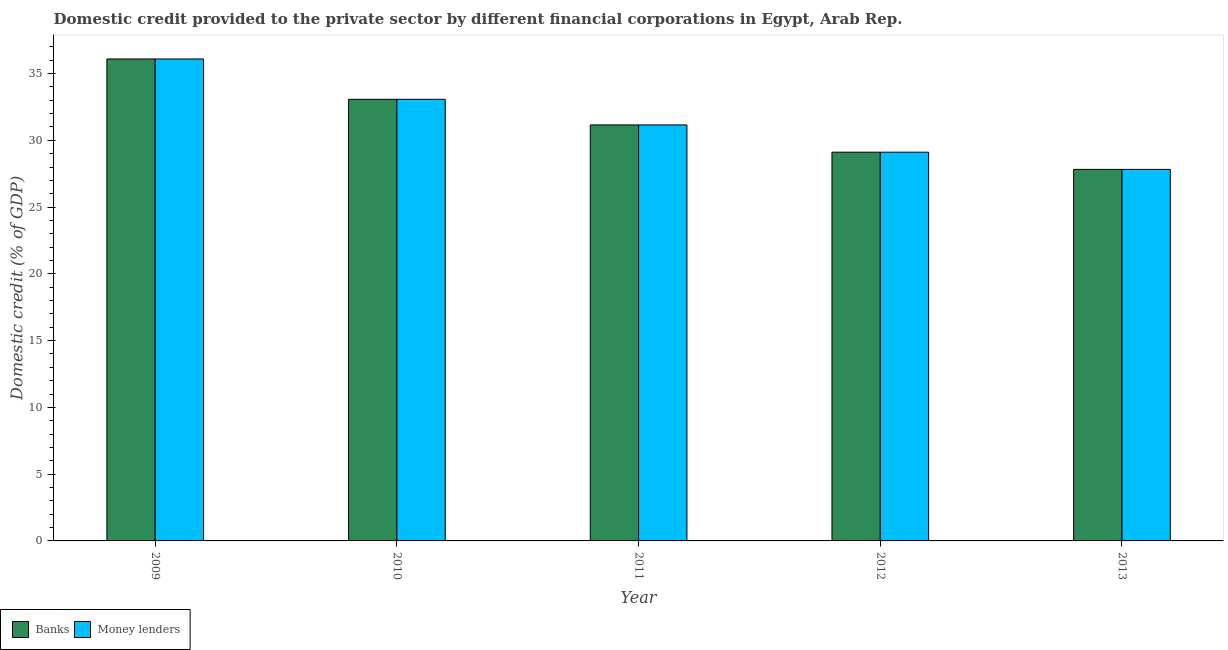Are the number of bars per tick equal to the number of legend labels?
Your answer should be compact. Yes. What is the domestic credit provided by banks in 2011?
Provide a succinct answer. 31.15. Across all years, what is the maximum domestic credit provided by money lenders?
Ensure brevity in your answer.  36.09. Across all years, what is the minimum domestic credit provided by money lenders?
Your response must be concise. 27.82. In which year was the domestic credit provided by money lenders maximum?
Give a very brief answer. 2009. What is the total domestic credit provided by money lenders in the graph?
Your response must be concise. 157.26. What is the difference between the domestic credit provided by banks in 2009 and that in 2011?
Your response must be concise. 4.94. What is the difference between the domestic credit provided by banks in 2011 and the domestic credit provided by money lenders in 2010?
Keep it short and to the point. -1.92. What is the average domestic credit provided by banks per year?
Offer a terse response. 31.45. In the year 2011, what is the difference between the domestic credit provided by banks and domestic credit provided by money lenders?
Your answer should be very brief. 0. What is the ratio of the domestic credit provided by money lenders in 2009 to that in 2012?
Ensure brevity in your answer.  1.24. Is the difference between the domestic credit provided by money lenders in 2012 and 2013 greater than the difference between the domestic credit provided by banks in 2012 and 2013?
Your answer should be compact. No. What is the difference between the highest and the second highest domestic credit provided by banks?
Your response must be concise. 3.02. What is the difference between the highest and the lowest domestic credit provided by money lenders?
Keep it short and to the point. 8.27. In how many years, is the domestic credit provided by banks greater than the average domestic credit provided by banks taken over all years?
Give a very brief answer. 2. What does the 2nd bar from the left in 2011 represents?
Your response must be concise. Money lenders. What does the 2nd bar from the right in 2013 represents?
Make the answer very short. Banks. How many years are there in the graph?
Offer a very short reply. 5. What is the difference between two consecutive major ticks on the Y-axis?
Your response must be concise. 5. Are the values on the major ticks of Y-axis written in scientific E-notation?
Provide a succinct answer. No. Does the graph contain grids?
Provide a short and direct response. No. How many legend labels are there?
Provide a succinct answer. 2. How are the legend labels stacked?
Provide a succinct answer. Horizontal. What is the title of the graph?
Ensure brevity in your answer.  Domestic credit provided to the private sector by different financial corporations in Egypt, Arab Rep. What is the label or title of the X-axis?
Make the answer very short. Year. What is the label or title of the Y-axis?
Give a very brief answer. Domestic credit (% of GDP). What is the Domestic credit (% of GDP) in Banks in 2009?
Provide a short and direct response. 36.09. What is the Domestic credit (% of GDP) in Money lenders in 2009?
Offer a very short reply. 36.09. What is the Domestic credit (% of GDP) of Banks in 2010?
Offer a very short reply. 33.07. What is the Domestic credit (% of GDP) of Money lenders in 2010?
Provide a short and direct response. 33.07. What is the Domestic credit (% of GDP) of Banks in 2011?
Make the answer very short. 31.15. What is the Domestic credit (% of GDP) of Money lenders in 2011?
Provide a short and direct response. 31.15. What is the Domestic credit (% of GDP) in Banks in 2012?
Your answer should be compact. 29.11. What is the Domestic credit (% of GDP) in Money lenders in 2012?
Offer a terse response. 29.11. What is the Domestic credit (% of GDP) in Banks in 2013?
Provide a succinct answer. 27.82. What is the Domestic credit (% of GDP) in Money lenders in 2013?
Give a very brief answer. 27.82. Across all years, what is the maximum Domestic credit (% of GDP) of Banks?
Make the answer very short. 36.09. Across all years, what is the maximum Domestic credit (% of GDP) of Money lenders?
Your answer should be very brief. 36.09. Across all years, what is the minimum Domestic credit (% of GDP) of Banks?
Offer a terse response. 27.82. Across all years, what is the minimum Domestic credit (% of GDP) of Money lenders?
Provide a succinct answer. 27.82. What is the total Domestic credit (% of GDP) in Banks in the graph?
Give a very brief answer. 157.26. What is the total Domestic credit (% of GDP) in Money lenders in the graph?
Give a very brief answer. 157.26. What is the difference between the Domestic credit (% of GDP) of Banks in 2009 and that in 2010?
Give a very brief answer. 3.02. What is the difference between the Domestic credit (% of GDP) of Money lenders in 2009 and that in 2010?
Make the answer very short. 3.02. What is the difference between the Domestic credit (% of GDP) in Banks in 2009 and that in 2011?
Your answer should be compact. 4.94. What is the difference between the Domestic credit (% of GDP) of Money lenders in 2009 and that in 2011?
Provide a short and direct response. 4.94. What is the difference between the Domestic credit (% of GDP) in Banks in 2009 and that in 2012?
Offer a very short reply. 6.98. What is the difference between the Domestic credit (% of GDP) in Money lenders in 2009 and that in 2012?
Provide a succinct answer. 6.98. What is the difference between the Domestic credit (% of GDP) of Banks in 2009 and that in 2013?
Offer a terse response. 8.27. What is the difference between the Domestic credit (% of GDP) of Money lenders in 2009 and that in 2013?
Give a very brief answer. 8.27. What is the difference between the Domestic credit (% of GDP) of Banks in 2010 and that in 2011?
Provide a succinct answer. 1.92. What is the difference between the Domestic credit (% of GDP) in Money lenders in 2010 and that in 2011?
Offer a terse response. 1.92. What is the difference between the Domestic credit (% of GDP) in Banks in 2010 and that in 2012?
Offer a terse response. 3.96. What is the difference between the Domestic credit (% of GDP) of Money lenders in 2010 and that in 2012?
Make the answer very short. 3.96. What is the difference between the Domestic credit (% of GDP) of Banks in 2010 and that in 2013?
Ensure brevity in your answer.  5.25. What is the difference between the Domestic credit (% of GDP) of Money lenders in 2010 and that in 2013?
Your answer should be very brief. 5.25. What is the difference between the Domestic credit (% of GDP) of Banks in 2011 and that in 2012?
Offer a very short reply. 2.04. What is the difference between the Domestic credit (% of GDP) of Money lenders in 2011 and that in 2012?
Keep it short and to the point. 2.04. What is the difference between the Domestic credit (% of GDP) in Banks in 2011 and that in 2013?
Ensure brevity in your answer.  3.33. What is the difference between the Domestic credit (% of GDP) of Money lenders in 2011 and that in 2013?
Ensure brevity in your answer.  3.33. What is the difference between the Domestic credit (% of GDP) in Banks in 2012 and that in 2013?
Your response must be concise. 1.29. What is the difference between the Domestic credit (% of GDP) in Money lenders in 2012 and that in 2013?
Offer a very short reply. 1.29. What is the difference between the Domestic credit (% of GDP) of Banks in 2009 and the Domestic credit (% of GDP) of Money lenders in 2010?
Your answer should be very brief. 3.02. What is the difference between the Domestic credit (% of GDP) in Banks in 2009 and the Domestic credit (% of GDP) in Money lenders in 2011?
Provide a succinct answer. 4.94. What is the difference between the Domestic credit (% of GDP) in Banks in 2009 and the Domestic credit (% of GDP) in Money lenders in 2012?
Make the answer very short. 6.98. What is the difference between the Domestic credit (% of GDP) of Banks in 2009 and the Domestic credit (% of GDP) of Money lenders in 2013?
Your response must be concise. 8.27. What is the difference between the Domestic credit (% of GDP) of Banks in 2010 and the Domestic credit (% of GDP) of Money lenders in 2011?
Offer a terse response. 1.92. What is the difference between the Domestic credit (% of GDP) of Banks in 2010 and the Domestic credit (% of GDP) of Money lenders in 2012?
Offer a terse response. 3.96. What is the difference between the Domestic credit (% of GDP) in Banks in 2010 and the Domestic credit (% of GDP) in Money lenders in 2013?
Ensure brevity in your answer.  5.25. What is the difference between the Domestic credit (% of GDP) in Banks in 2011 and the Domestic credit (% of GDP) in Money lenders in 2012?
Keep it short and to the point. 2.04. What is the difference between the Domestic credit (% of GDP) in Banks in 2011 and the Domestic credit (% of GDP) in Money lenders in 2013?
Your answer should be very brief. 3.33. What is the difference between the Domestic credit (% of GDP) of Banks in 2012 and the Domestic credit (% of GDP) of Money lenders in 2013?
Keep it short and to the point. 1.29. What is the average Domestic credit (% of GDP) of Banks per year?
Offer a terse response. 31.45. What is the average Domestic credit (% of GDP) in Money lenders per year?
Provide a succinct answer. 31.45. In the year 2009, what is the difference between the Domestic credit (% of GDP) in Banks and Domestic credit (% of GDP) in Money lenders?
Offer a terse response. 0. In the year 2011, what is the difference between the Domestic credit (% of GDP) of Banks and Domestic credit (% of GDP) of Money lenders?
Offer a terse response. 0. In the year 2012, what is the difference between the Domestic credit (% of GDP) in Banks and Domestic credit (% of GDP) in Money lenders?
Offer a terse response. 0. In the year 2013, what is the difference between the Domestic credit (% of GDP) of Banks and Domestic credit (% of GDP) of Money lenders?
Make the answer very short. 0. What is the ratio of the Domestic credit (% of GDP) of Banks in 2009 to that in 2010?
Your answer should be very brief. 1.09. What is the ratio of the Domestic credit (% of GDP) of Money lenders in 2009 to that in 2010?
Keep it short and to the point. 1.09. What is the ratio of the Domestic credit (% of GDP) in Banks in 2009 to that in 2011?
Make the answer very short. 1.16. What is the ratio of the Domestic credit (% of GDP) of Money lenders in 2009 to that in 2011?
Provide a succinct answer. 1.16. What is the ratio of the Domestic credit (% of GDP) in Banks in 2009 to that in 2012?
Make the answer very short. 1.24. What is the ratio of the Domestic credit (% of GDP) of Money lenders in 2009 to that in 2012?
Keep it short and to the point. 1.24. What is the ratio of the Domestic credit (% of GDP) of Banks in 2009 to that in 2013?
Your answer should be very brief. 1.3. What is the ratio of the Domestic credit (% of GDP) of Money lenders in 2009 to that in 2013?
Your response must be concise. 1.3. What is the ratio of the Domestic credit (% of GDP) in Banks in 2010 to that in 2011?
Ensure brevity in your answer.  1.06. What is the ratio of the Domestic credit (% of GDP) in Money lenders in 2010 to that in 2011?
Offer a terse response. 1.06. What is the ratio of the Domestic credit (% of GDP) of Banks in 2010 to that in 2012?
Give a very brief answer. 1.14. What is the ratio of the Domestic credit (% of GDP) in Money lenders in 2010 to that in 2012?
Offer a very short reply. 1.14. What is the ratio of the Domestic credit (% of GDP) in Banks in 2010 to that in 2013?
Make the answer very short. 1.19. What is the ratio of the Domestic credit (% of GDP) in Money lenders in 2010 to that in 2013?
Keep it short and to the point. 1.19. What is the ratio of the Domestic credit (% of GDP) in Banks in 2011 to that in 2012?
Your answer should be compact. 1.07. What is the ratio of the Domestic credit (% of GDP) of Money lenders in 2011 to that in 2012?
Offer a very short reply. 1.07. What is the ratio of the Domestic credit (% of GDP) in Banks in 2011 to that in 2013?
Keep it short and to the point. 1.12. What is the ratio of the Domestic credit (% of GDP) of Money lenders in 2011 to that in 2013?
Make the answer very short. 1.12. What is the ratio of the Domestic credit (% of GDP) of Banks in 2012 to that in 2013?
Make the answer very short. 1.05. What is the ratio of the Domestic credit (% of GDP) of Money lenders in 2012 to that in 2013?
Offer a terse response. 1.05. What is the difference between the highest and the second highest Domestic credit (% of GDP) of Banks?
Provide a succinct answer. 3.02. What is the difference between the highest and the second highest Domestic credit (% of GDP) of Money lenders?
Offer a terse response. 3.02. What is the difference between the highest and the lowest Domestic credit (% of GDP) in Banks?
Offer a terse response. 8.27. What is the difference between the highest and the lowest Domestic credit (% of GDP) of Money lenders?
Provide a succinct answer. 8.27. 